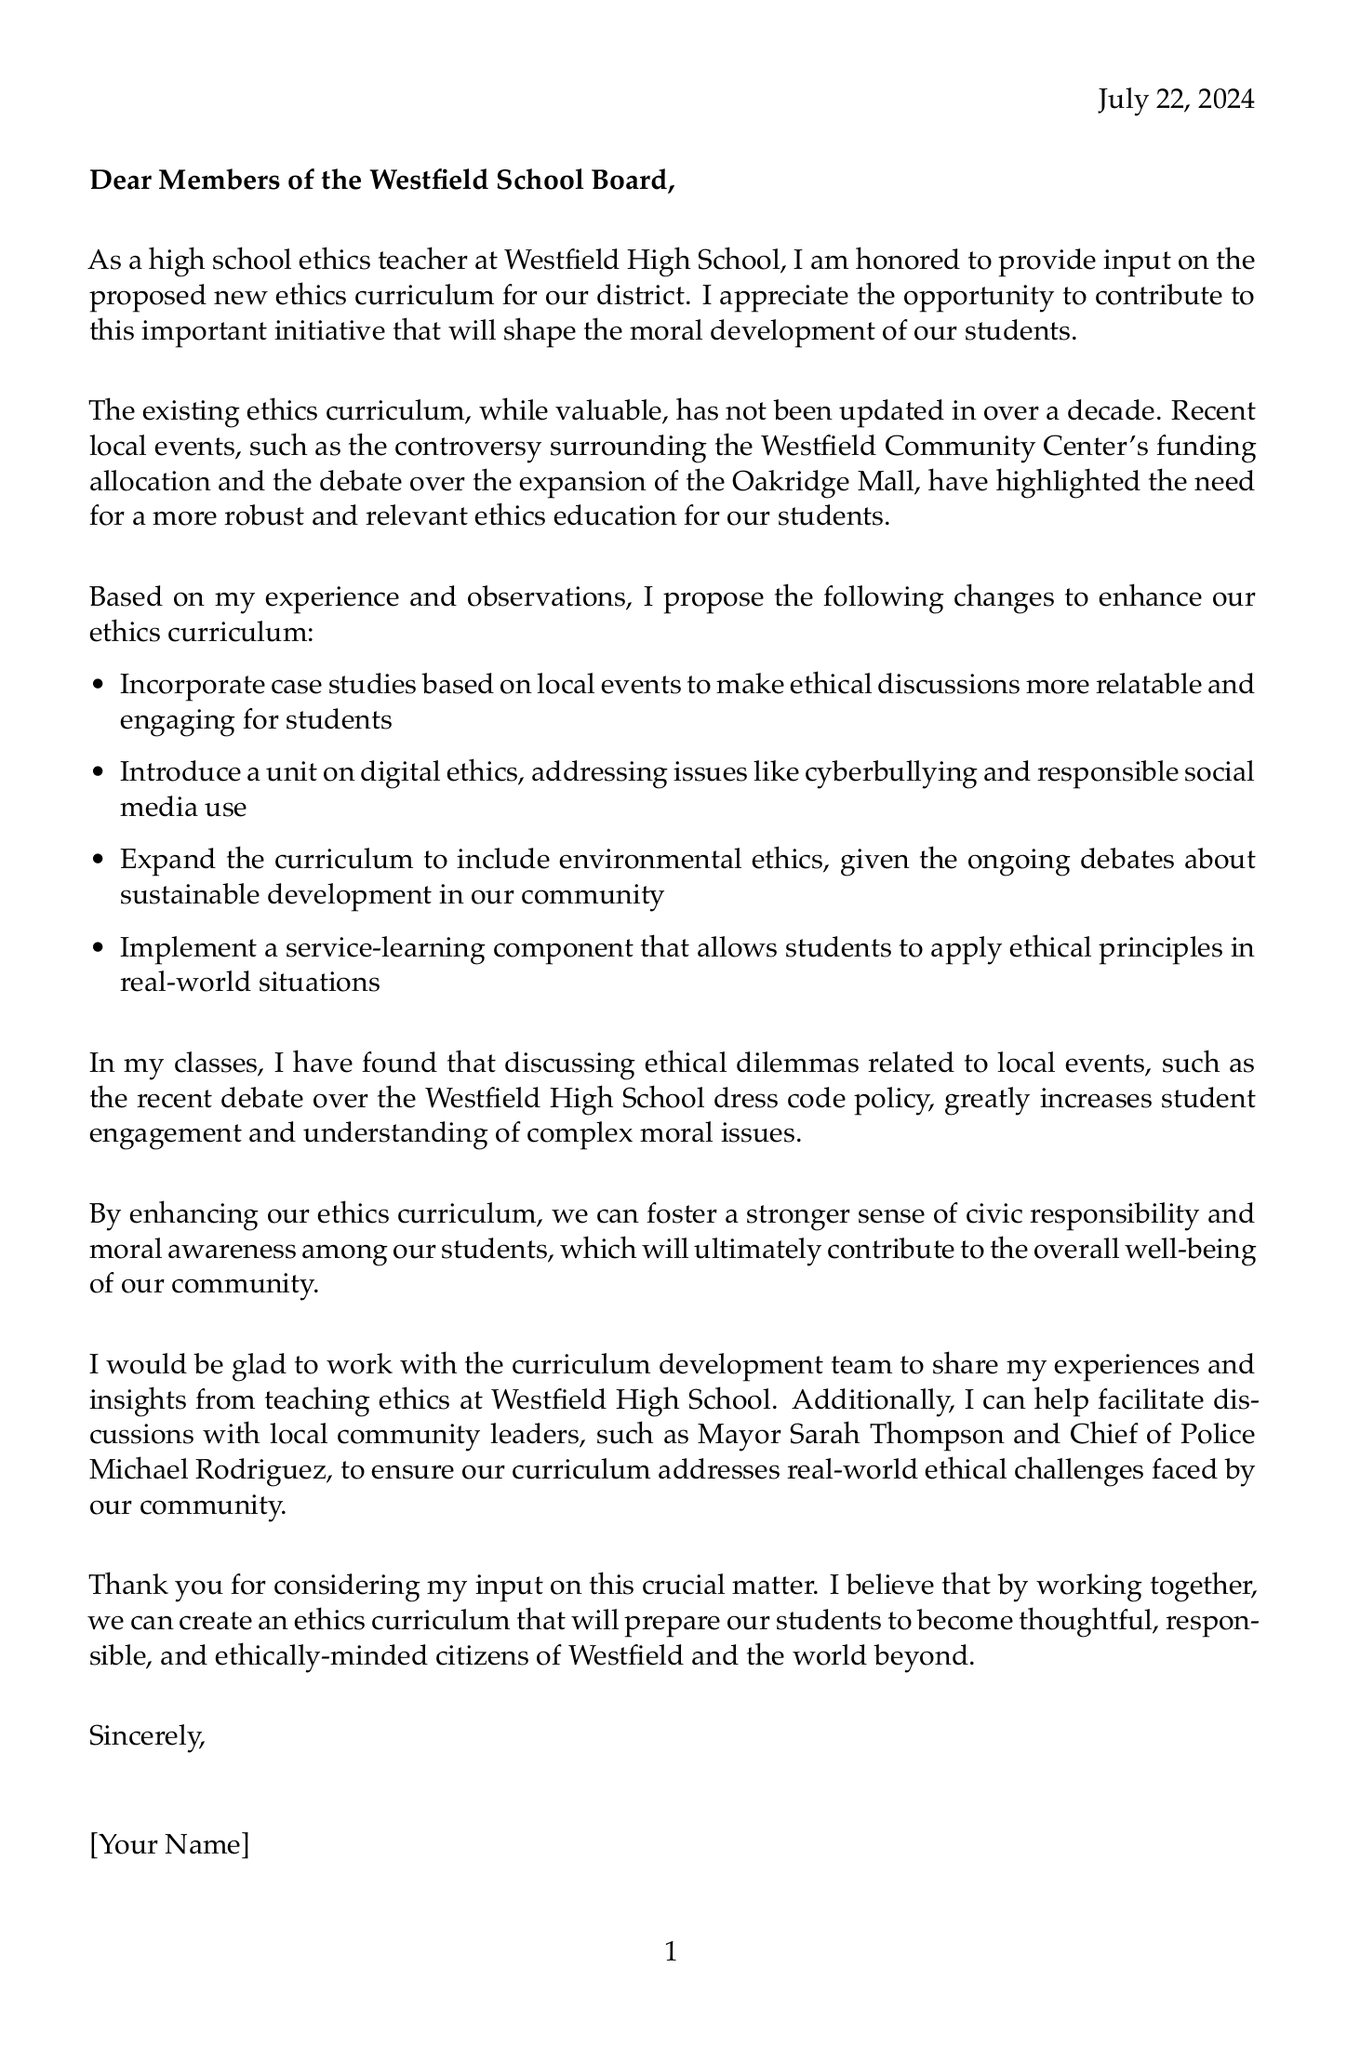what is the salutation of the letter? The salutation is the greeting at the beginning of the letter, addressed to the school board members.
Answer: Dear Members of the Westfield School Board, what is the main purpose of the letter? The main purpose is to provide input on a new ethics curriculum for the district.
Answer: Input on the proposed new ethics curriculum how many proposed changes to the curriculum are listed? The number of proposed changes is specified in the list presented in the document.
Answer: Four what local event is mentioned related to funding allocation? The specific local event refers to a community issue that has sparked debate.
Answer: Westfield Community Center's funding allocation who is mentioned as a community leader in the letter? The letter names a local community leader that could help address ethical challenges.
Answer: Mayor Sarah Thompson what addition to the curriculum focuses on technology? This addition addresses moral considerations around modern technology.
Answer: Digital ethics how has the existing ethics curriculum been described in the letter? The letter provides a view of how current educational materials have been maintained over time.
Answer: Not been updated in over a decade what is one challenge listed in implementing the new curriculum? This challenge addresses concerns around how discussions may influence educational views.
Answer: Ensuring the curriculum remains neutral on controversial local issues what type of component is proposed to help students apply ethical principles? This type of component allows practical application of ethics in real situations.
Answer: Service-learning component 